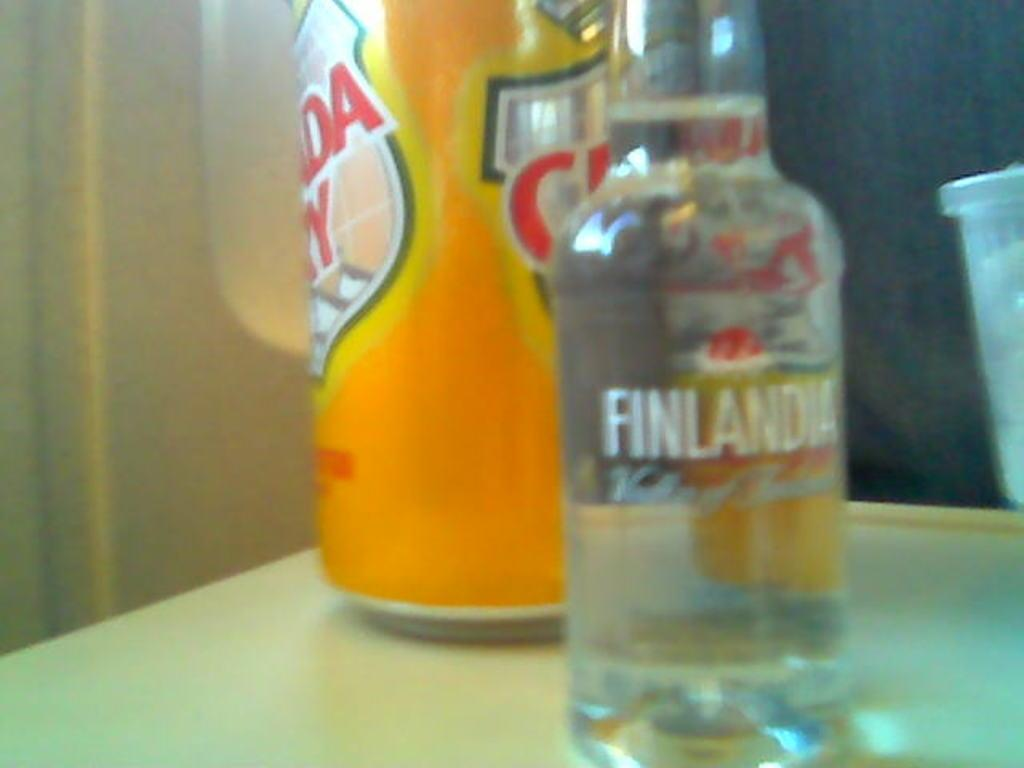<image>
Describe the image concisely. A bottle with the label Finlandia stands on a tray table of an airplane. 